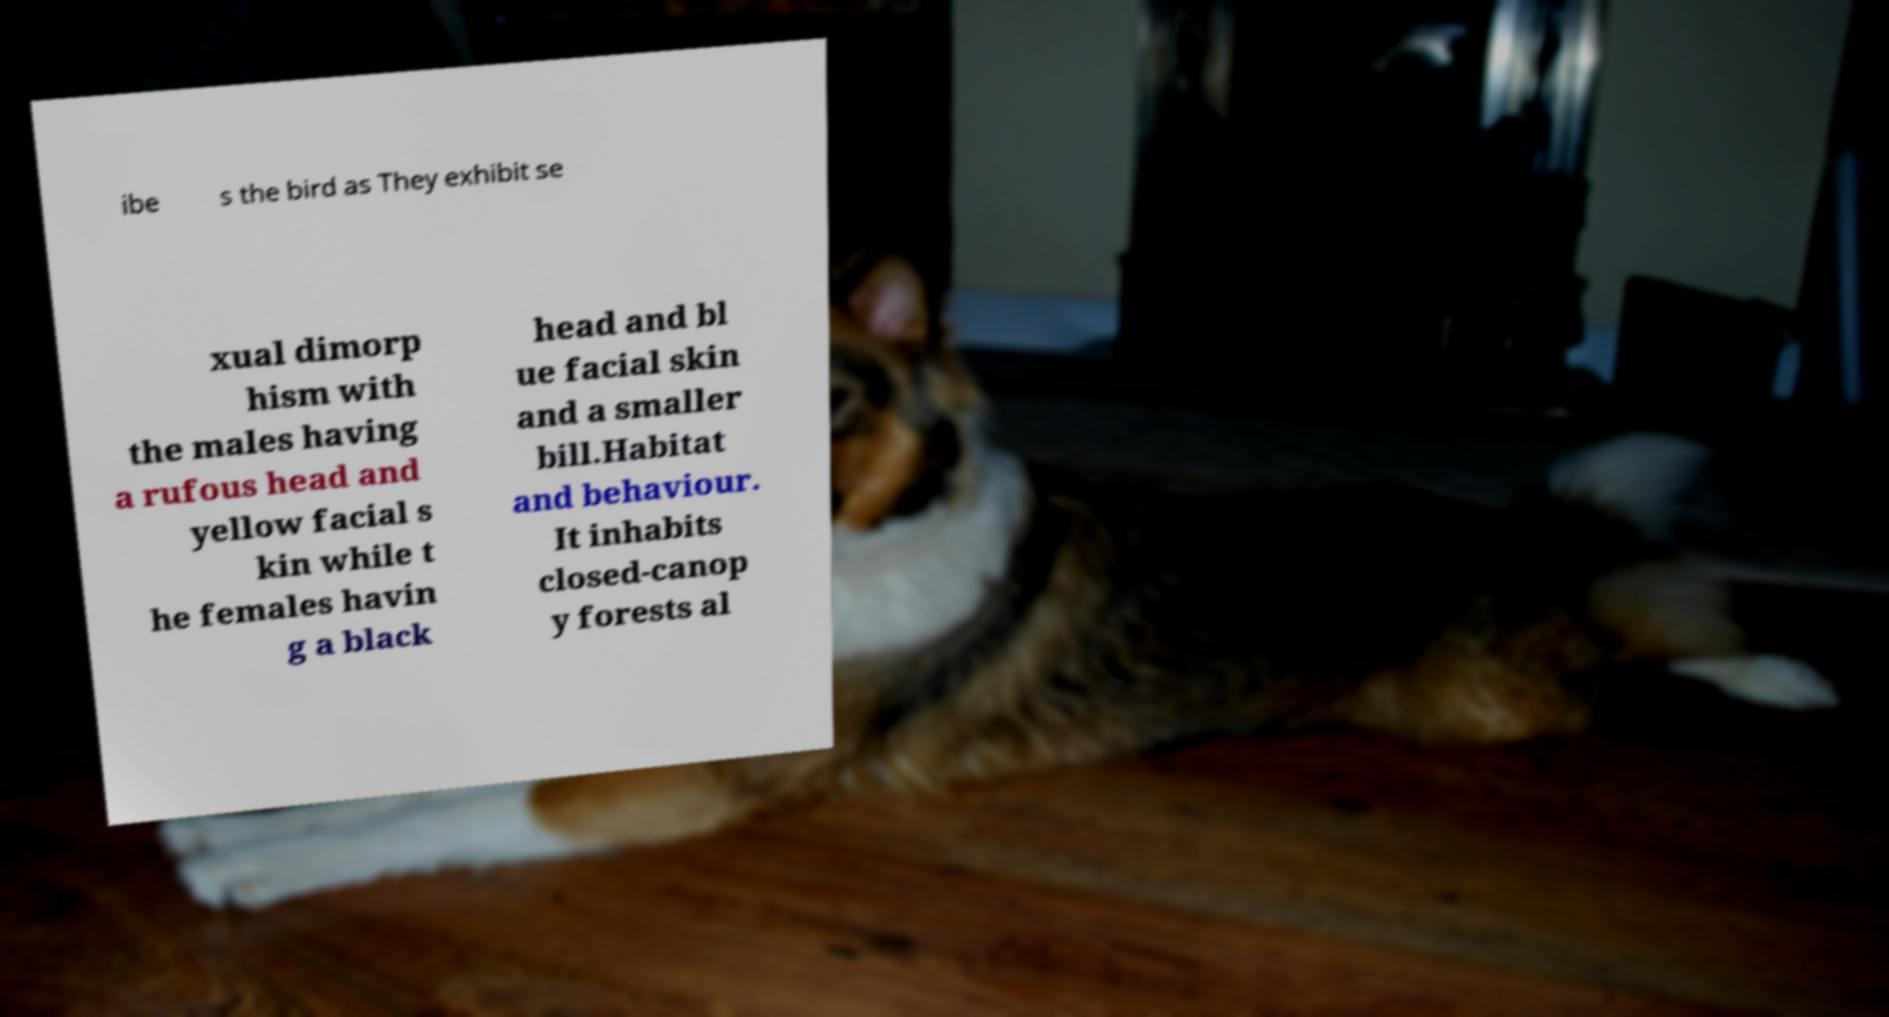Could you extract and type out the text from this image? ibe s the bird as They exhibit se xual dimorp hism with the males having a rufous head and yellow facial s kin while t he females havin g a black head and bl ue facial skin and a smaller bill.Habitat and behaviour. It inhabits closed-canop y forests al 